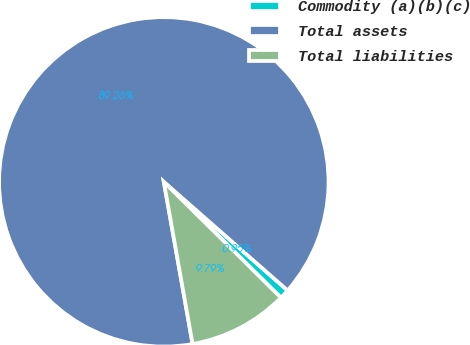Convert chart to OTSL. <chart><loc_0><loc_0><loc_500><loc_500><pie_chart><fcel>Commodity (a)(b)(c)<fcel>Total assets<fcel>Total liabilities<nl><fcel>0.95%<fcel>89.26%<fcel>9.79%<nl></chart> 